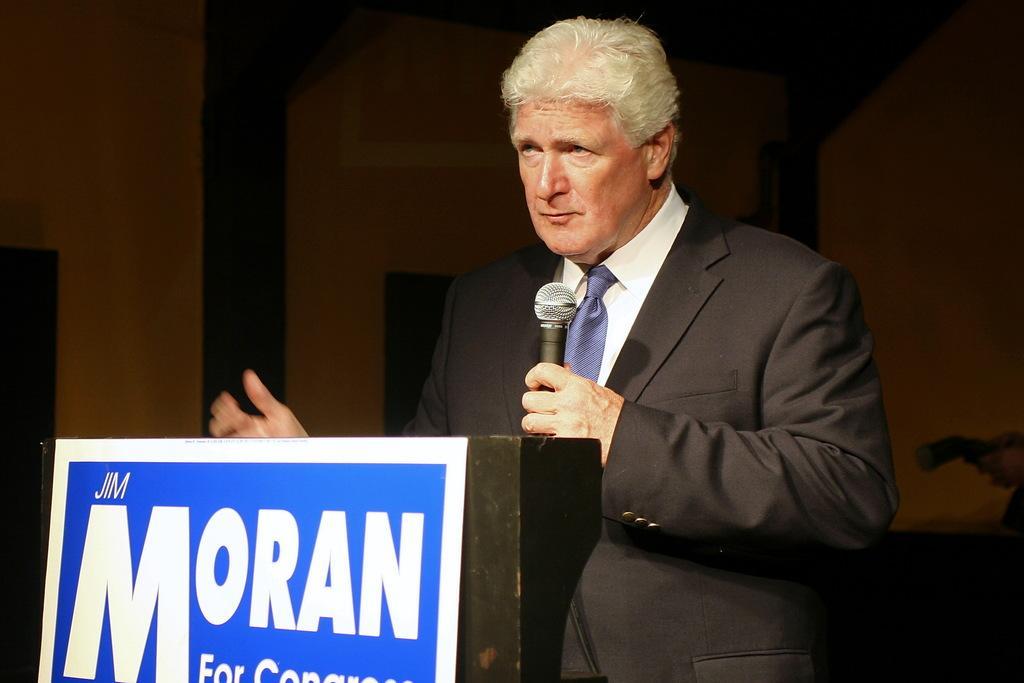Could you give a brief overview of what you see in this image? In this image we can see a person holding a mic and standing near a podium. There is a board on which there is some text. In the background of the image there is wall. 